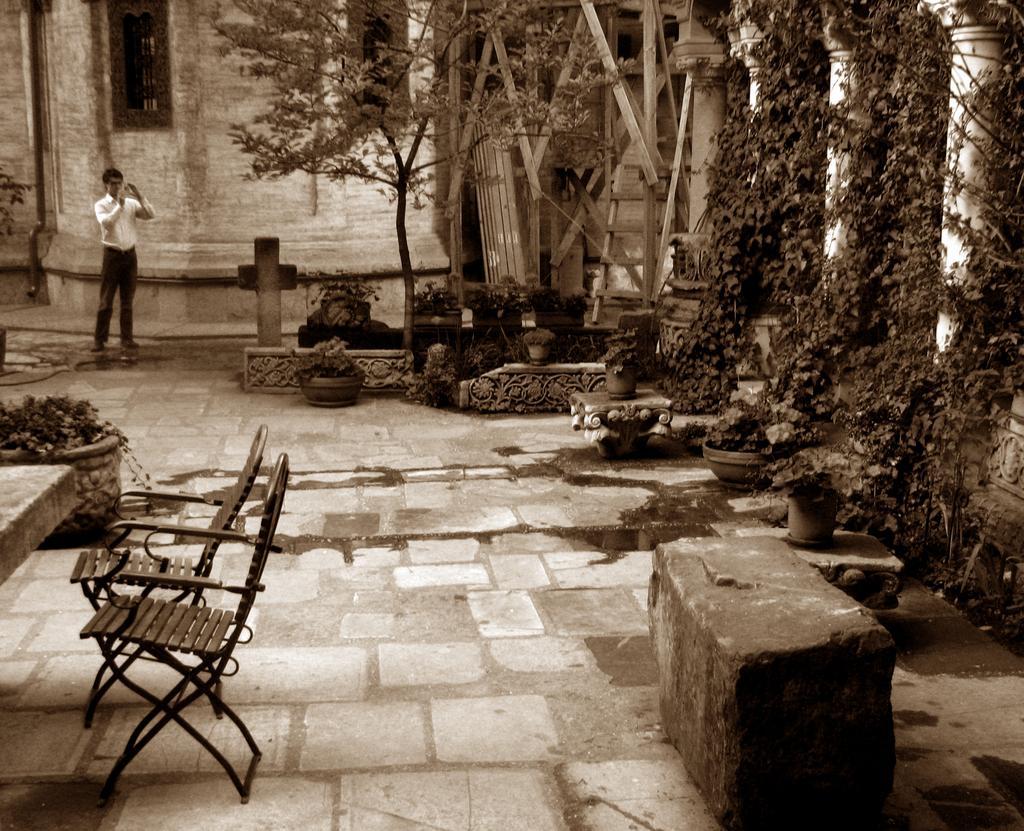Could you give a brief overview of what you see in this image? In this image we can see one building, some pillars, some pots with plants, one cross, one object on the left side looks like a table, two chairs, some trees, some plants on the ground, one object near the pillar looks like a ladder, one small pillar, one man standing and holding one object looks like a camera. 